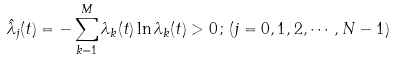Convert formula to latex. <formula><loc_0><loc_0><loc_500><loc_500>\hat { \lambda } _ { j } ( t ) = - \sum _ { k = 1 } ^ { M } \lambda _ { k } ( t ) \ln \lambda _ { k } ( t ) > 0 \, ; \, ( j = 0 , 1 , 2 , \cdots , N - 1 )</formula> 